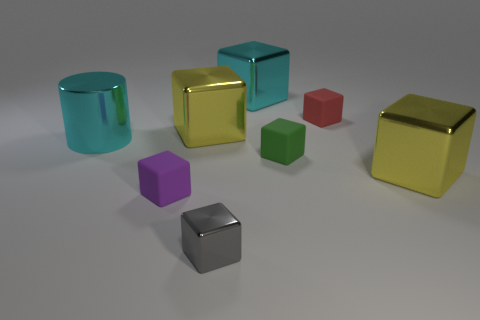How many yellow cubes must be subtracted to get 1 yellow cubes? 1 Subtract all purple rubber cubes. How many cubes are left? 6 Subtract all yellow blocks. How many blocks are left? 5 Subtract all cyan blocks. Subtract all red balls. How many blocks are left? 6 Add 1 large cyan cylinders. How many objects exist? 9 Subtract all blocks. How many objects are left? 1 Add 3 cyan metal cubes. How many cyan metal cubes are left? 4 Add 7 big yellow spheres. How many big yellow spheres exist? 7 Subtract 0 purple balls. How many objects are left? 8 Subtract all tiny red matte cubes. Subtract all large red matte things. How many objects are left? 7 